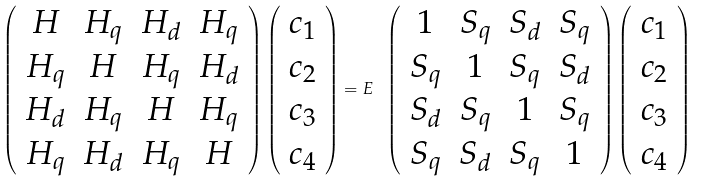Convert formula to latex. <formula><loc_0><loc_0><loc_500><loc_500>\left ( \begin{array} { c c c c } H & H _ { q } & H _ { d } & H _ { q } \\ H _ { q } & H & H _ { q } & H _ { d } \\ H _ { d } & H _ { q } & H & H _ { q } \\ H _ { q } & H _ { d } & H _ { q } & H \end{array} \right ) \left ( \begin{array} { c } c _ { 1 } \\ c _ { 2 } \\ c _ { 3 } \\ c _ { 4 } \end{array} \right ) = E \ \left ( \begin{array} { c c c c } 1 & S _ { q } & S _ { d } & S _ { q } \\ S _ { q } & 1 & S _ { q } & S _ { d } \\ S _ { d } & S _ { q } & 1 & S _ { q } \\ S _ { q } & S _ { d } & S _ { q } & 1 \end{array} \right ) \left ( \begin{array} { c } c _ { 1 } \\ c _ { 2 } \\ c _ { 3 } \\ c _ { 4 } \end{array} \right )</formula> 